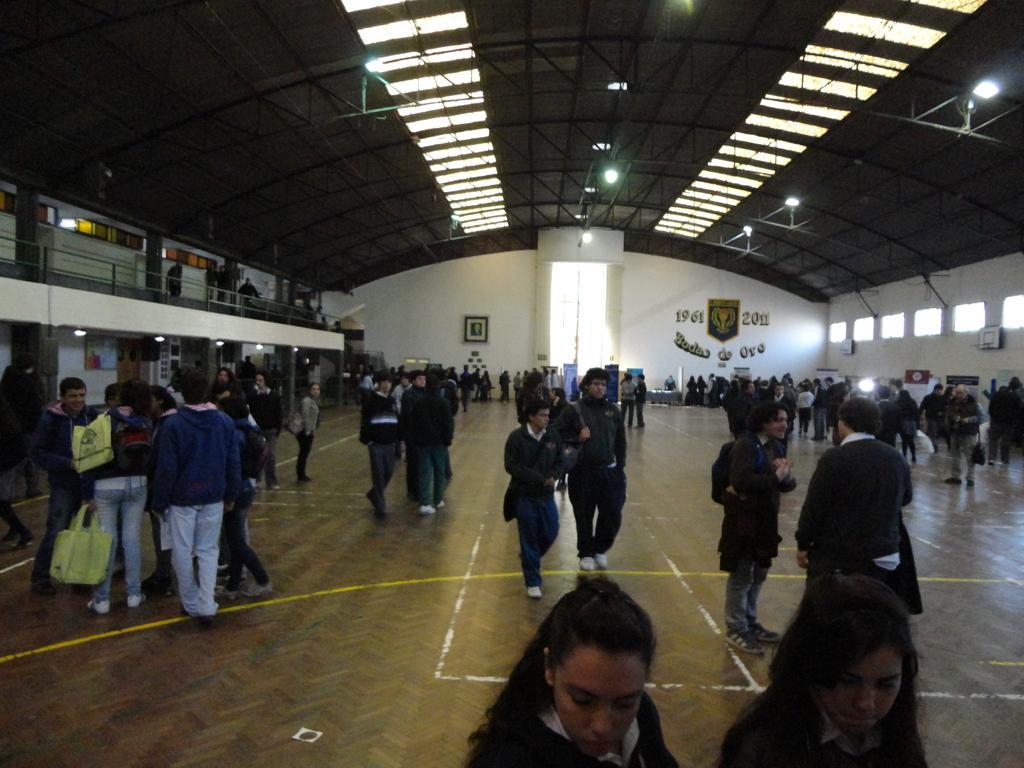Describe this image in one or two sentences. In this image we can see some people, bags and other objects. In the background of the image there is a wall, frames, persons and other objects. On the left side of the image there are persons, railing, wall, windows, lights and other objects. On the right side of the image there are windows, persons and other objects. At the top of the image there is roof, iron objects, lights and other objects. At the bottom of the image there is the floor and persons. 